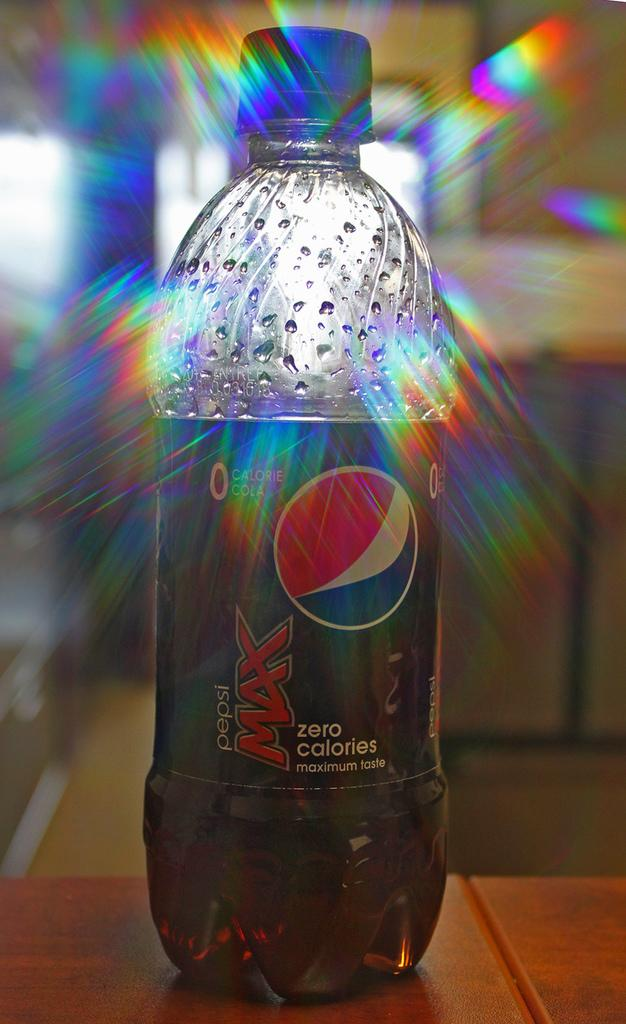<image>
Describe the image concisely. A bottle of Pepsi Max on a table is illuminated by a bright light. 